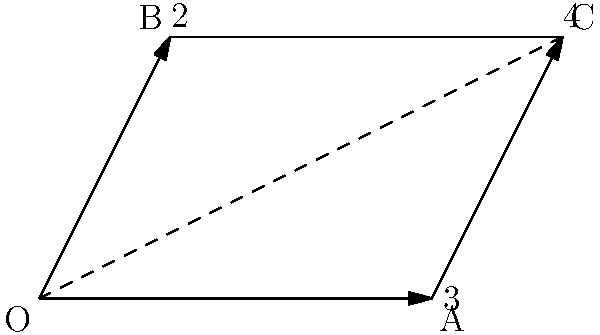In the parallelogram OABC shown above, $\vec{OA} = 3\hat{i}$ and $\vec{OB} = \hat{i} + 2\hat{j}$. Calculate the area of the parallelogram using the cross product method. How would this approach differ from traditional methods, and what advantages might it offer in a debate setting? Let's approach this step-by-step:

1) The area of a parallelogram can be calculated using the magnitude of the cross product of two adjacent sides.

2) We have $\vec{OA} = 3\hat{i}$ and $\vec{OB} = \hat{i} + 2\hat{j}$.

3) The cross product is given by:
   $$\vec{OA} \times \vec{OB} = \begin{vmatrix} 
   \hat{i} & \hat{j} & \hat{k} \\
   3 & 0 & 0 \\
   1 & 2 & 0
   \end{vmatrix}$$

4) Calculating the determinant:
   $$(3 \cdot 2 - 0 \cdot 1)\hat{k} = 6\hat{k}$$

5) The magnitude of this vector is 6, which is the area of the parallelogram.

In a debate setting, this approach offers several advantages:
- It's more generalized and can be applied to 3D problems.
- It introduces vector algebra, demonstrating a higher level of mathematical sophistication.
- It connects geometry with linear algebra, showing interdisciplinary thinking.
- The cross product method is faster for complex shapes, potentially giving a time advantage in rapid debate scenarios.
Answer: 6 square units 